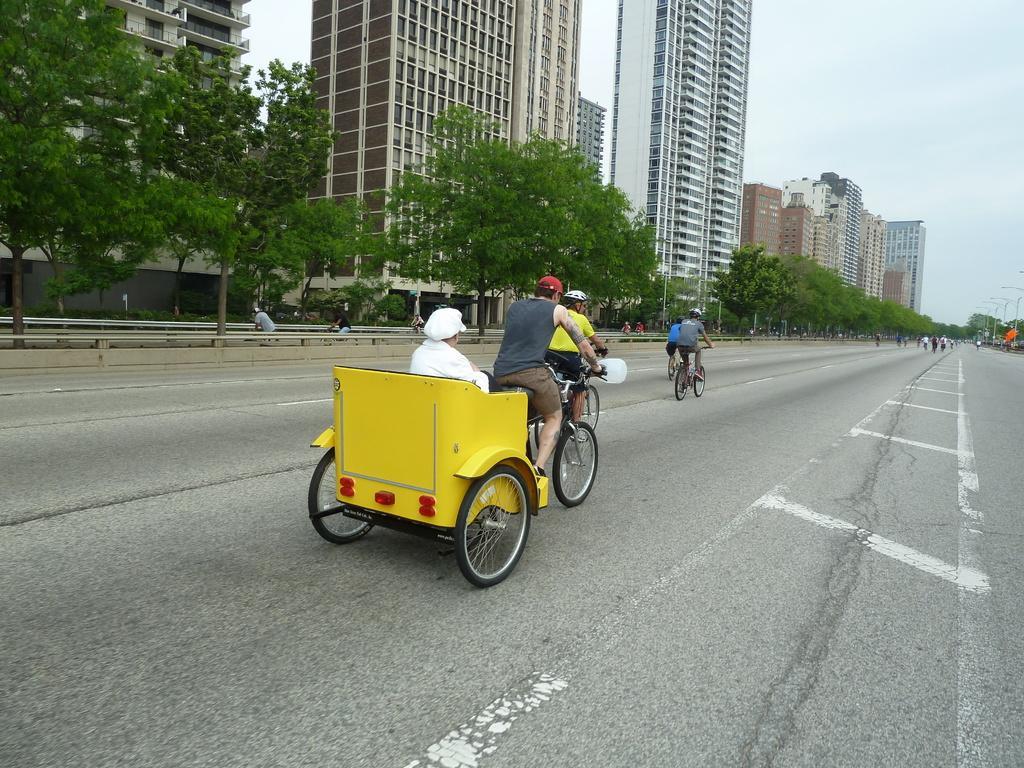Describe this image in one or two sentences. A man is riding a rickshaw on this road and there are trees. Behind them there are big buildings. 